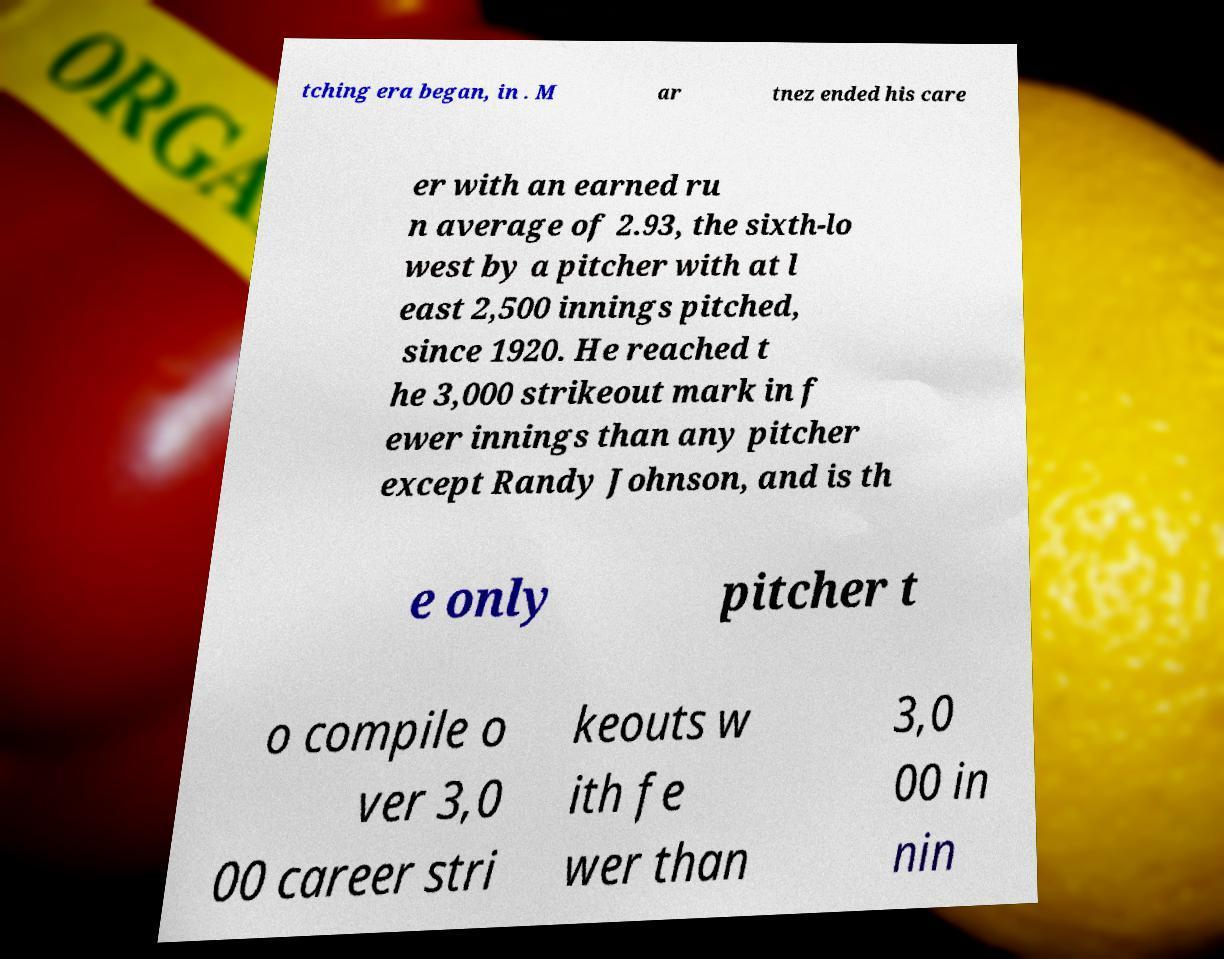What messages or text are displayed in this image? I need them in a readable, typed format. tching era began, in . M ar tnez ended his care er with an earned ru n average of 2.93, the sixth-lo west by a pitcher with at l east 2,500 innings pitched, since 1920. He reached t he 3,000 strikeout mark in f ewer innings than any pitcher except Randy Johnson, and is th e only pitcher t o compile o ver 3,0 00 career stri keouts w ith fe wer than 3,0 00 in nin 